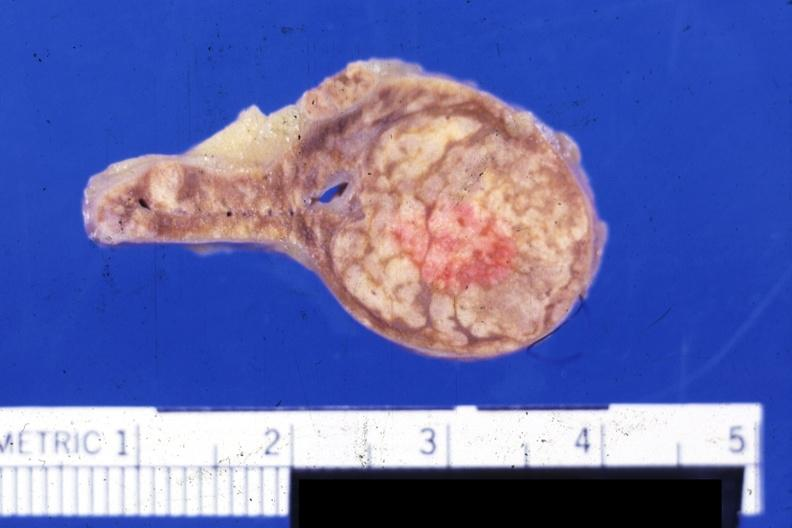what does this image show?
Answer the question using a single word or phrase. Fixed tissue nice close-up of moderate size cortical nodule or adenoma 